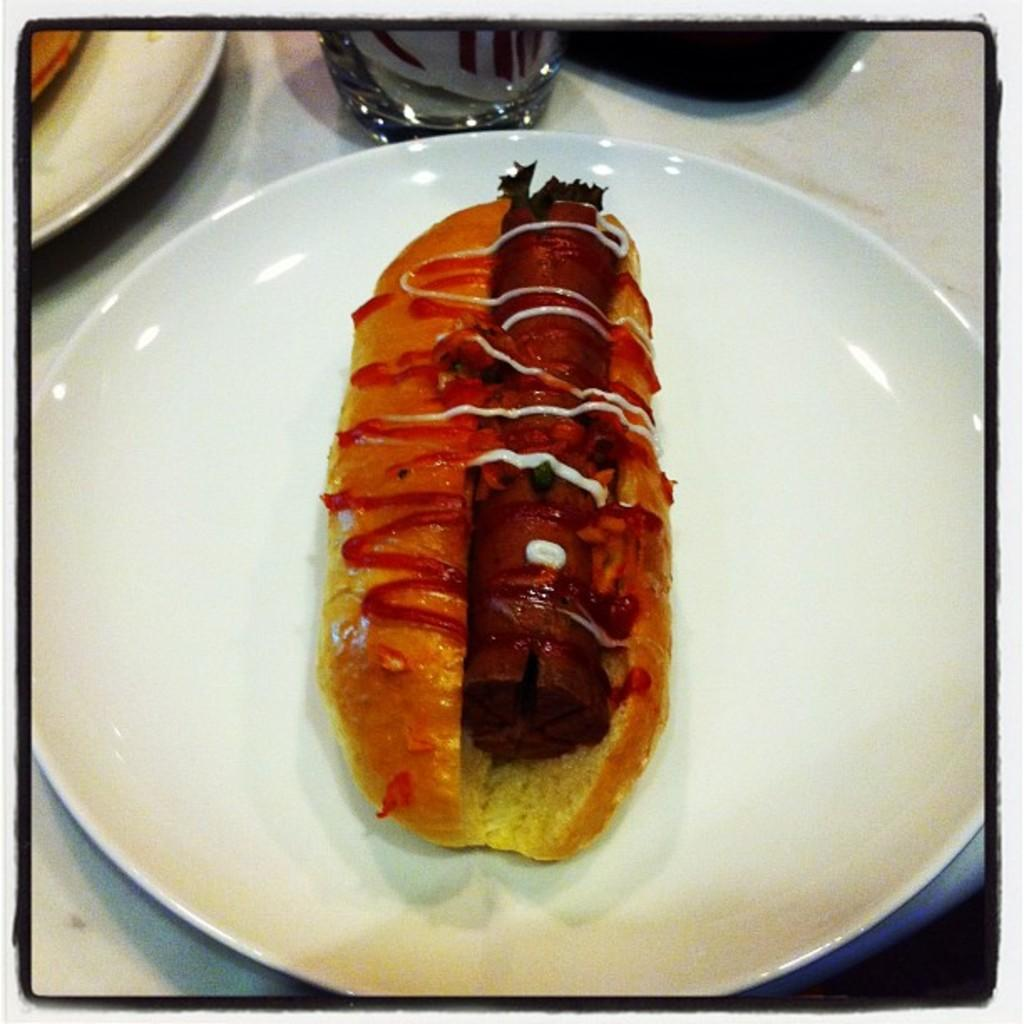What is present on the plate in the image? There is a food item on the plate in the image. Can you describe the food item on the plate? Unfortunately, the facts provided do not specify the type of food item on the plate. What is the level of wealth depicted in the image? There is no indication of wealth in the image, as it only features a plate with a food item on it. How does the image look during the winter season? The facts provided do not specify the time of year or the season in which the image was taken, so it cannot be determined if the image looks like winter. 